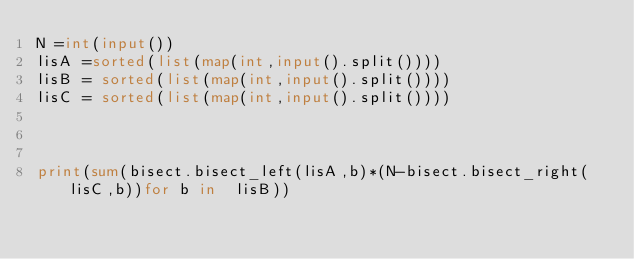<code> <loc_0><loc_0><loc_500><loc_500><_Python_>N =int(input())
lisA =sorted(list(map(int,input().split())))
lisB = sorted(list(map(int,input().split())))
lisC = sorted(list(map(int,input().split())))



print(sum(bisect.bisect_left(lisA,b)*(N-bisect.bisect_right(lisC,b))for b in  lisB))</code> 